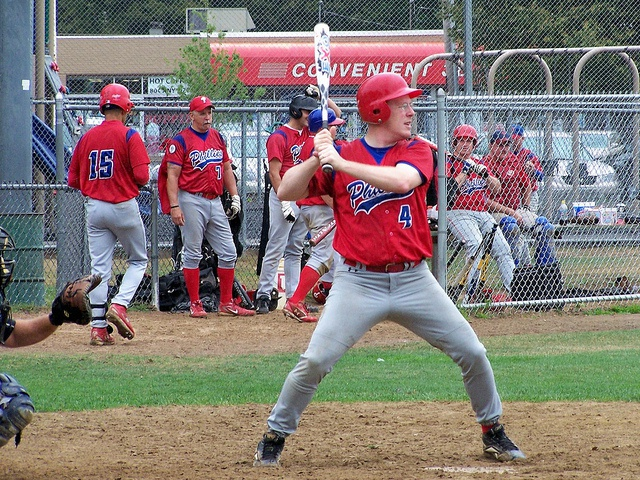Describe the objects in this image and their specific colors. I can see people in blue, gray, brown, darkgray, and lightgray tones, people in blue, brown, gray, and darkgray tones, people in blue, brown, black, darkgray, and gray tones, people in blue, black, gray, maroon, and darkgray tones, and people in blue, darkgray, gray, and black tones in this image. 